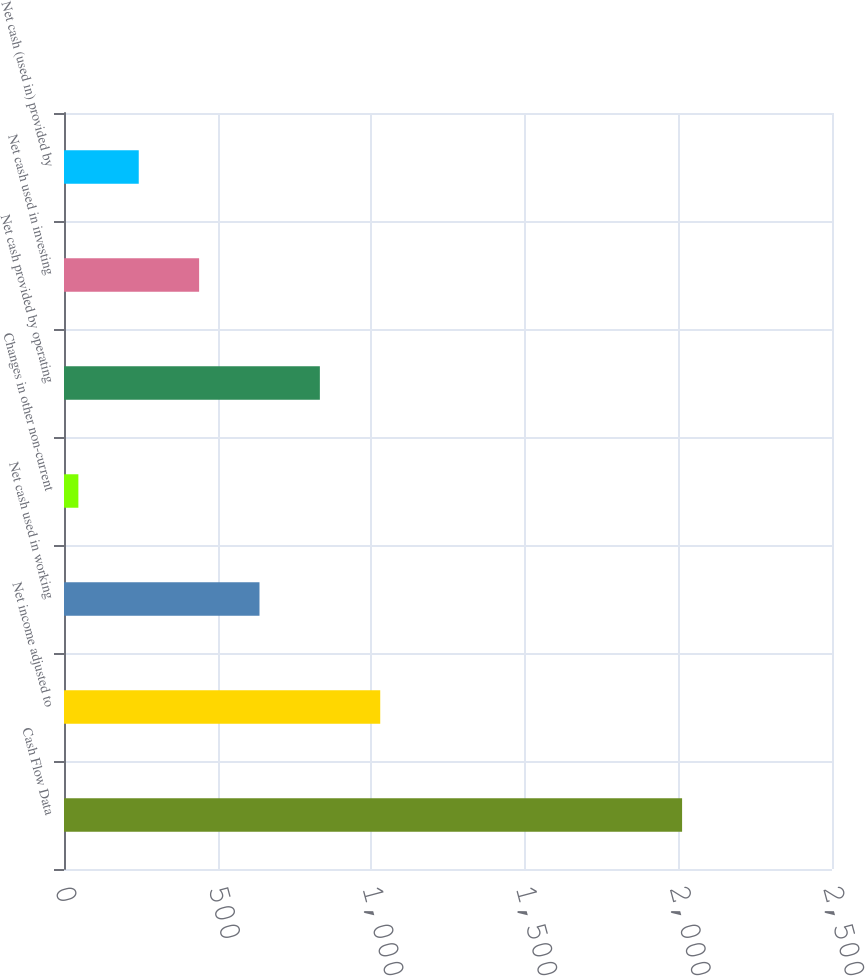Convert chart. <chart><loc_0><loc_0><loc_500><loc_500><bar_chart><fcel>Cash Flow Data<fcel>Net income adjusted to<fcel>Net cash used in working<fcel>Changes in other non-current<fcel>Net cash provided by operating<fcel>Net cash used in investing<fcel>Net cash (used in) provided by<nl><fcel>2012<fcel>1029.4<fcel>636.36<fcel>46.8<fcel>832.88<fcel>439.84<fcel>243.32<nl></chart> 